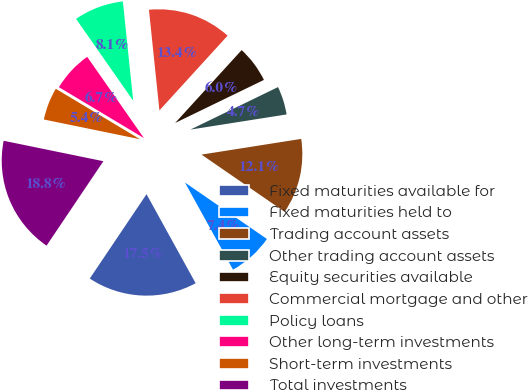<chart> <loc_0><loc_0><loc_500><loc_500><pie_chart><fcel>Fixed maturities available for<fcel>Fixed maturities held to<fcel>Trading account assets<fcel>Other trading account assets<fcel>Equity securities available<fcel>Commercial mortgage and other<fcel>Policy loans<fcel>Other long-term investments<fcel>Short-term investments<fcel>Total investments<nl><fcel>17.45%<fcel>7.38%<fcel>12.08%<fcel>4.7%<fcel>6.04%<fcel>13.42%<fcel>8.05%<fcel>6.71%<fcel>5.37%<fcel>18.79%<nl></chart> 